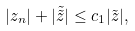<formula> <loc_0><loc_0><loc_500><loc_500>| z _ { n } | + | \tilde { \tilde { z } } | \leq c _ { 1 } | \tilde { z } | ,</formula> 